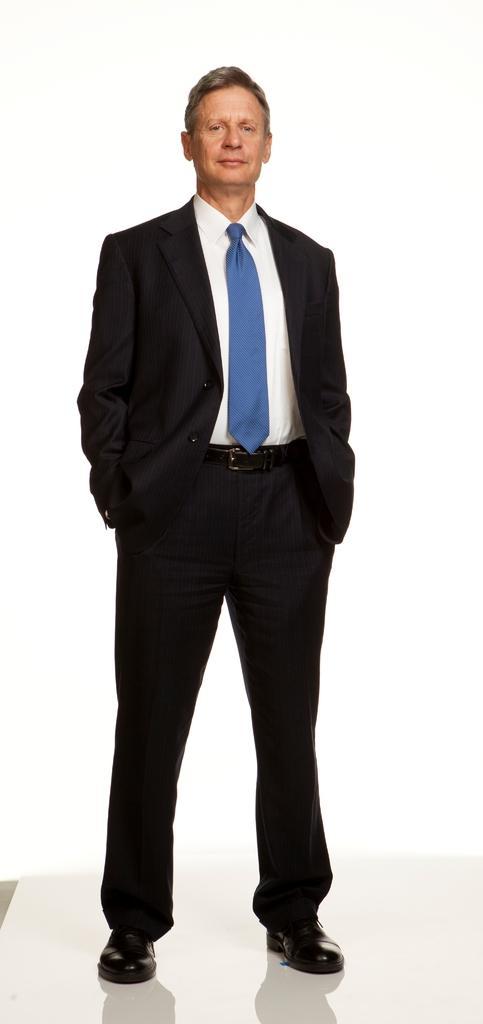Please provide a concise description of this image. In this image the person standing in the white color background. And he wears a white shirt, blue tie, black coat and black shoes. 